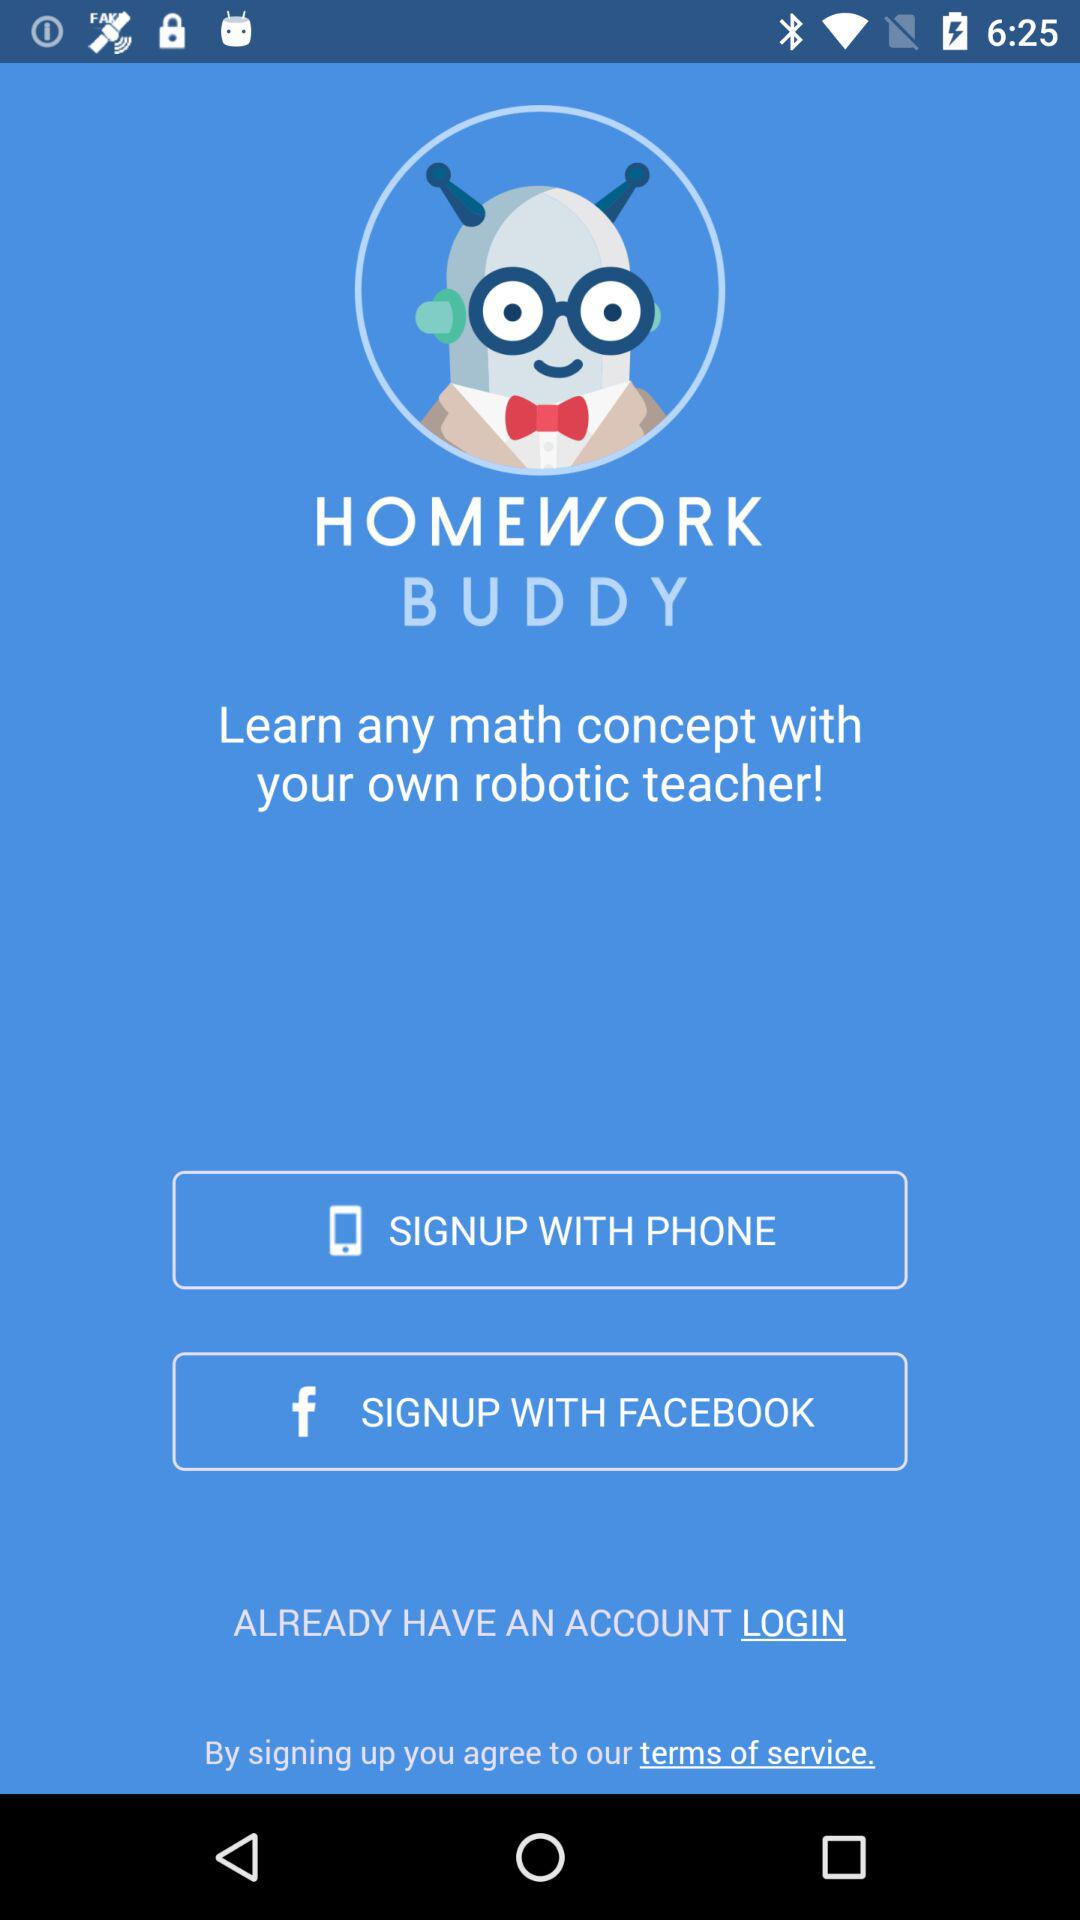How many signup options are there?
Answer the question using a single word or phrase. 2 